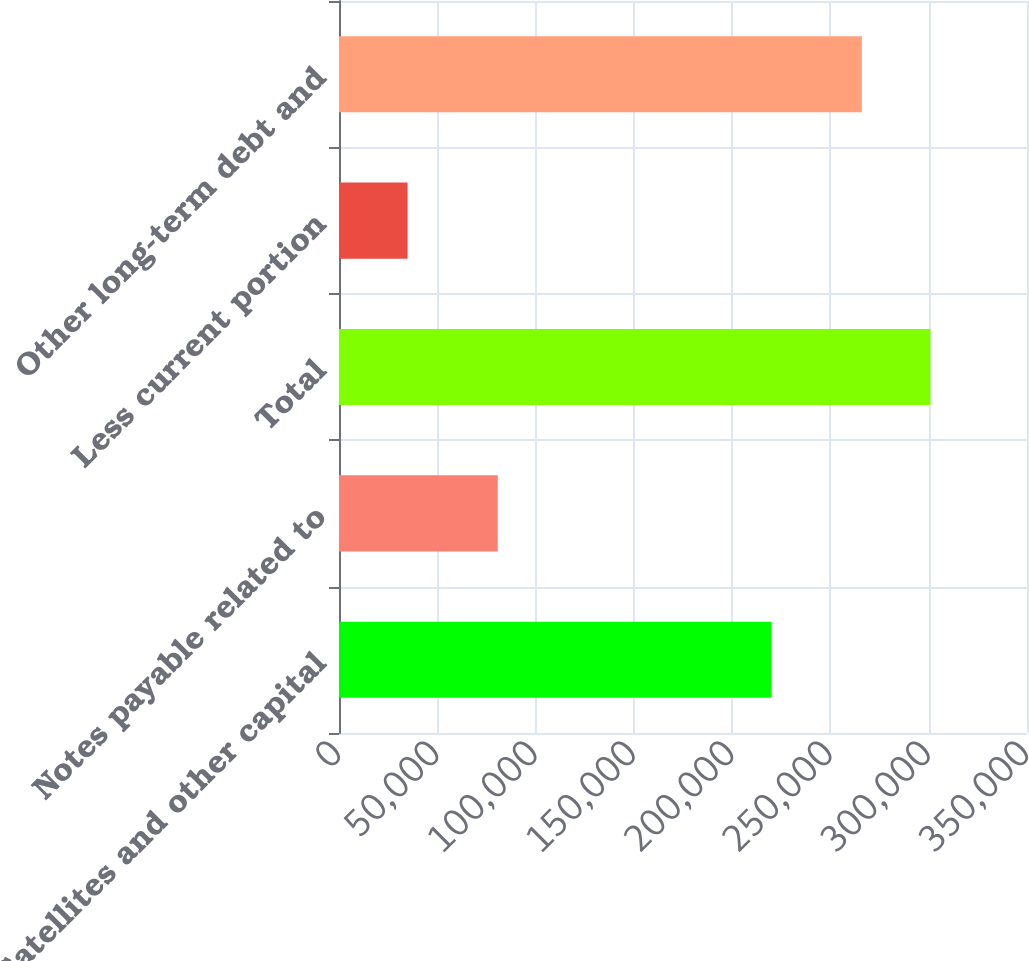<chart> <loc_0><loc_0><loc_500><loc_500><bar_chart><fcel>Satellites and other capital<fcel>Notes payable related to<fcel>Total<fcel>Less current portion<fcel>Other long-term debt and<nl><fcel>220115<fcel>80769<fcel>300884<fcel>34893<fcel>265991<nl></chart> 